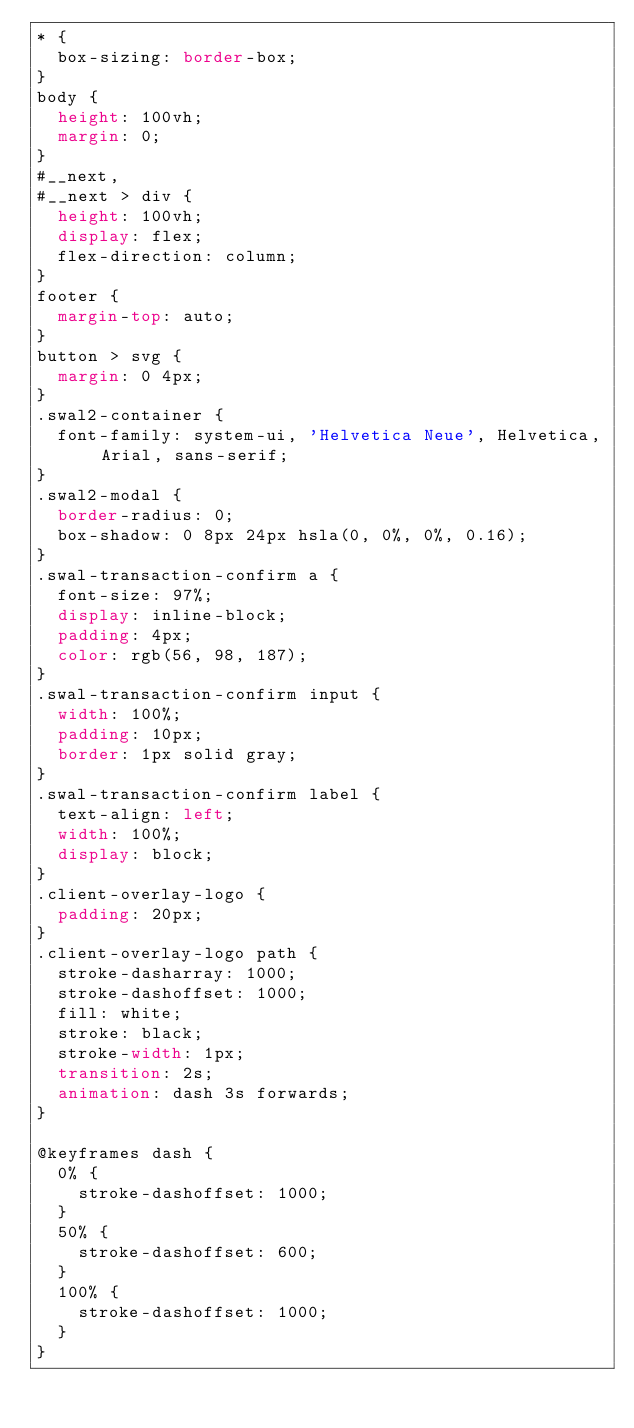Convert code to text. <code><loc_0><loc_0><loc_500><loc_500><_CSS_>* {
  box-sizing: border-box;
}
body {
  height: 100vh;
  margin: 0;
}
#__next,
#__next > div {
  height: 100vh;
  display: flex;
  flex-direction: column;
}
footer {
  margin-top: auto;
}
button > svg {
  margin: 0 4px;
}
.swal2-container {
  font-family: system-ui, 'Helvetica Neue', Helvetica, Arial, sans-serif;
}
.swal2-modal {
  border-radius: 0;
  box-shadow: 0 8px 24px hsla(0, 0%, 0%, 0.16);
}
.swal-transaction-confirm a {
  font-size: 97%;
  display: inline-block;
  padding: 4px;
  color: rgb(56, 98, 187);
}
.swal-transaction-confirm input {
  width: 100%;
  padding: 10px;
  border: 1px solid gray;
}
.swal-transaction-confirm label {
  text-align: left;
  width: 100%;
  display: block;
}
.client-overlay-logo {
  padding: 20px;
}
.client-overlay-logo path {
  stroke-dasharray: 1000;
  stroke-dashoffset: 1000;
  fill: white;
  stroke: black;
  stroke-width: 1px;
  transition: 2s;
  animation: dash 3s forwards;
}

@keyframes dash {
  0% {
    stroke-dashoffset: 1000;
  }
  50% {
    stroke-dashoffset: 600;
  }
  100% {
    stroke-dashoffset: 1000;
  }
}
</code> 